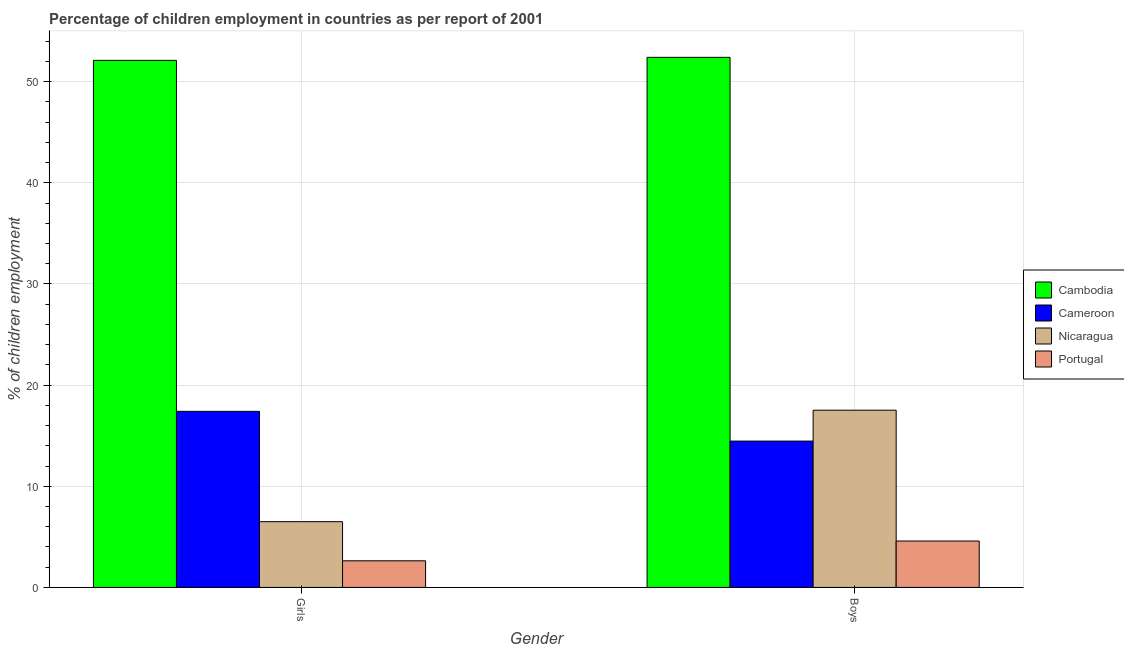How many bars are there on the 1st tick from the left?
Provide a short and direct response. 4. How many bars are there on the 1st tick from the right?
Provide a short and direct response. 4. What is the label of the 1st group of bars from the left?
Make the answer very short. Girls. What is the percentage of employed boys in Cameroon?
Your response must be concise. 14.47. Across all countries, what is the maximum percentage of employed boys?
Your answer should be compact. 52.4. Across all countries, what is the minimum percentage of employed boys?
Keep it short and to the point. 4.59. In which country was the percentage of employed girls maximum?
Offer a very short reply. Cambodia. In which country was the percentage of employed girls minimum?
Keep it short and to the point. Portugal. What is the total percentage of employed boys in the graph?
Keep it short and to the point. 88.97. What is the difference between the percentage of employed boys in Nicaragua and that in Cambodia?
Offer a terse response. -34.88. What is the difference between the percentage of employed boys in Cameroon and the percentage of employed girls in Nicaragua?
Make the answer very short. 7.97. What is the average percentage of employed boys per country?
Your answer should be very brief. 22.24. What is the difference between the percentage of employed girls and percentage of employed boys in Portugal?
Your response must be concise. -1.95. In how many countries, is the percentage of employed boys greater than 2 %?
Give a very brief answer. 4. What is the ratio of the percentage of employed boys in Cambodia to that in Portugal?
Keep it short and to the point. 11.43. What does the 3rd bar from the left in Girls represents?
Ensure brevity in your answer.  Nicaragua. What does the 1st bar from the right in Girls represents?
Provide a succinct answer. Portugal. How many bars are there?
Provide a succinct answer. 8. How many countries are there in the graph?
Make the answer very short. 4. What is the difference between two consecutive major ticks on the Y-axis?
Offer a terse response. 10. Does the graph contain any zero values?
Your response must be concise. No. Does the graph contain grids?
Make the answer very short. Yes. Where does the legend appear in the graph?
Offer a terse response. Center right. How are the legend labels stacked?
Your answer should be compact. Vertical. What is the title of the graph?
Your answer should be very brief. Percentage of children employment in countries as per report of 2001. What is the label or title of the X-axis?
Make the answer very short. Gender. What is the label or title of the Y-axis?
Keep it short and to the point. % of children employment. What is the % of children employment in Cambodia in Girls?
Offer a terse response. 52.1. What is the % of children employment of Cameroon in Girls?
Your answer should be compact. 17.41. What is the % of children employment in Nicaragua in Girls?
Your response must be concise. 6.5. What is the % of children employment of Portugal in Girls?
Ensure brevity in your answer.  2.63. What is the % of children employment of Cambodia in Boys?
Provide a succinct answer. 52.4. What is the % of children employment in Cameroon in Boys?
Make the answer very short. 14.47. What is the % of children employment in Nicaragua in Boys?
Make the answer very short. 17.52. What is the % of children employment of Portugal in Boys?
Give a very brief answer. 4.59. Across all Gender, what is the maximum % of children employment in Cambodia?
Ensure brevity in your answer.  52.4. Across all Gender, what is the maximum % of children employment in Cameroon?
Ensure brevity in your answer.  17.41. Across all Gender, what is the maximum % of children employment of Nicaragua?
Give a very brief answer. 17.52. Across all Gender, what is the maximum % of children employment in Portugal?
Offer a very short reply. 4.59. Across all Gender, what is the minimum % of children employment in Cambodia?
Your answer should be very brief. 52.1. Across all Gender, what is the minimum % of children employment in Cameroon?
Make the answer very short. 14.47. Across all Gender, what is the minimum % of children employment of Nicaragua?
Your answer should be very brief. 6.5. Across all Gender, what is the minimum % of children employment in Portugal?
Your answer should be very brief. 2.63. What is the total % of children employment in Cambodia in the graph?
Your answer should be very brief. 104.5. What is the total % of children employment in Cameroon in the graph?
Give a very brief answer. 31.87. What is the total % of children employment in Nicaragua in the graph?
Offer a very short reply. 24.02. What is the total % of children employment in Portugal in the graph?
Provide a short and direct response. 7.22. What is the difference between the % of children employment of Cambodia in Girls and that in Boys?
Give a very brief answer. -0.3. What is the difference between the % of children employment of Cameroon in Girls and that in Boys?
Make the answer very short. 2.94. What is the difference between the % of children employment in Nicaragua in Girls and that in Boys?
Offer a very short reply. -11.02. What is the difference between the % of children employment in Portugal in Girls and that in Boys?
Provide a short and direct response. -1.95. What is the difference between the % of children employment of Cambodia in Girls and the % of children employment of Cameroon in Boys?
Make the answer very short. 37.63. What is the difference between the % of children employment of Cambodia in Girls and the % of children employment of Nicaragua in Boys?
Provide a short and direct response. 34.58. What is the difference between the % of children employment in Cambodia in Girls and the % of children employment in Portugal in Boys?
Make the answer very short. 47.51. What is the difference between the % of children employment of Cameroon in Girls and the % of children employment of Nicaragua in Boys?
Provide a succinct answer. -0.11. What is the difference between the % of children employment of Cameroon in Girls and the % of children employment of Portugal in Boys?
Provide a succinct answer. 12.82. What is the difference between the % of children employment in Nicaragua in Girls and the % of children employment in Portugal in Boys?
Your response must be concise. 1.91. What is the average % of children employment of Cambodia per Gender?
Give a very brief answer. 52.25. What is the average % of children employment in Cameroon per Gender?
Offer a very short reply. 15.94. What is the average % of children employment in Nicaragua per Gender?
Keep it short and to the point. 12.01. What is the average % of children employment in Portugal per Gender?
Your answer should be compact. 3.61. What is the difference between the % of children employment in Cambodia and % of children employment in Cameroon in Girls?
Ensure brevity in your answer.  34.69. What is the difference between the % of children employment of Cambodia and % of children employment of Nicaragua in Girls?
Provide a short and direct response. 45.6. What is the difference between the % of children employment in Cambodia and % of children employment in Portugal in Girls?
Offer a very short reply. 49.47. What is the difference between the % of children employment in Cameroon and % of children employment in Nicaragua in Girls?
Provide a succinct answer. 10.91. What is the difference between the % of children employment of Cameroon and % of children employment of Portugal in Girls?
Provide a succinct answer. 14.78. What is the difference between the % of children employment of Nicaragua and % of children employment of Portugal in Girls?
Offer a terse response. 3.87. What is the difference between the % of children employment of Cambodia and % of children employment of Cameroon in Boys?
Ensure brevity in your answer.  37.93. What is the difference between the % of children employment of Cambodia and % of children employment of Nicaragua in Boys?
Your answer should be very brief. 34.88. What is the difference between the % of children employment of Cambodia and % of children employment of Portugal in Boys?
Your answer should be compact. 47.81. What is the difference between the % of children employment of Cameroon and % of children employment of Nicaragua in Boys?
Keep it short and to the point. -3.05. What is the difference between the % of children employment of Cameroon and % of children employment of Portugal in Boys?
Your answer should be very brief. 9.88. What is the difference between the % of children employment in Nicaragua and % of children employment in Portugal in Boys?
Offer a very short reply. 12.93. What is the ratio of the % of children employment in Cameroon in Girls to that in Boys?
Offer a terse response. 1.2. What is the ratio of the % of children employment in Nicaragua in Girls to that in Boys?
Offer a very short reply. 0.37. What is the ratio of the % of children employment in Portugal in Girls to that in Boys?
Provide a succinct answer. 0.57. What is the difference between the highest and the second highest % of children employment of Cambodia?
Provide a succinct answer. 0.3. What is the difference between the highest and the second highest % of children employment of Cameroon?
Provide a short and direct response. 2.94. What is the difference between the highest and the second highest % of children employment of Nicaragua?
Provide a short and direct response. 11.02. What is the difference between the highest and the second highest % of children employment of Portugal?
Provide a succinct answer. 1.95. What is the difference between the highest and the lowest % of children employment in Cameroon?
Your answer should be very brief. 2.94. What is the difference between the highest and the lowest % of children employment in Nicaragua?
Your answer should be very brief. 11.02. What is the difference between the highest and the lowest % of children employment of Portugal?
Give a very brief answer. 1.95. 